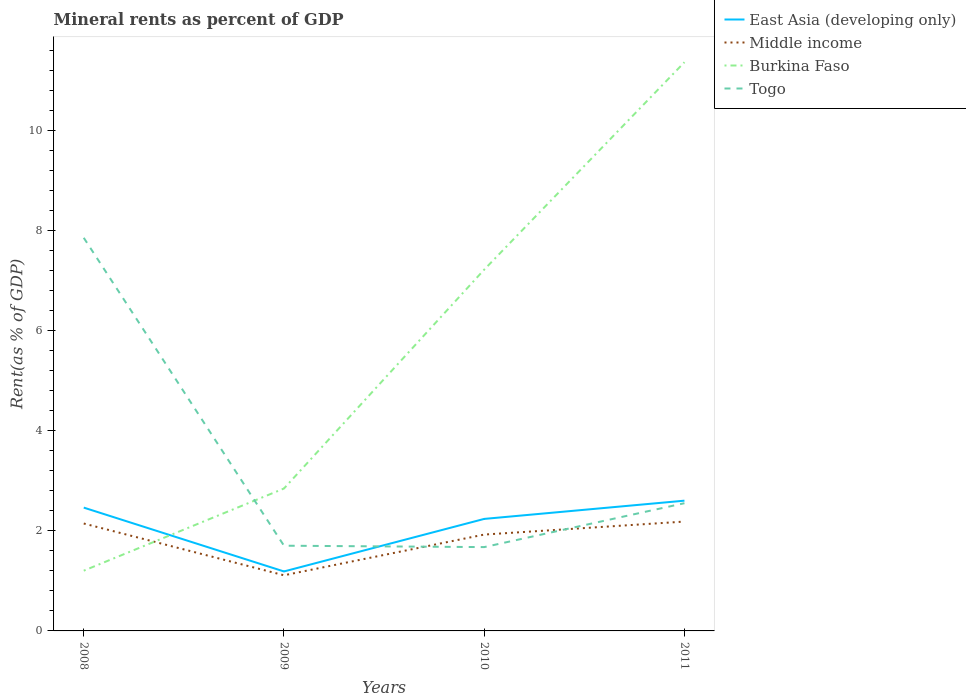How many different coloured lines are there?
Offer a terse response. 4. Does the line corresponding to Togo intersect with the line corresponding to Burkina Faso?
Your answer should be compact. Yes. Is the number of lines equal to the number of legend labels?
Your answer should be very brief. Yes. Across all years, what is the maximum mineral rent in Burkina Faso?
Keep it short and to the point. 1.2. What is the total mineral rent in Togo in the graph?
Give a very brief answer. 0.03. What is the difference between the highest and the second highest mineral rent in Burkina Faso?
Your answer should be very brief. 10.15. What is the difference between the highest and the lowest mineral rent in Middle income?
Offer a terse response. 3. Is the mineral rent in Togo strictly greater than the mineral rent in Burkina Faso over the years?
Offer a very short reply. No. What is the difference between two consecutive major ticks on the Y-axis?
Give a very brief answer. 2. Does the graph contain any zero values?
Your answer should be compact. No. How many legend labels are there?
Offer a very short reply. 4. How are the legend labels stacked?
Offer a very short reply. Vertical. What is the title of the graph?
Ensure brevity in your answer.  Mineral rents as percent of GDP. Does "Vietnam" appear as one of the legend labels in the graph?
Offer a very short reply. No. What is the label or title of the X-axis?
Make the answer very short. Years. What is the label or title of the Y-axis?
Give a very brief answer. Rent(as % of GDP). What is the Rent(as % of GDP) in East Asia (developing only) in 2008?
Make the answer very short. 2.46. What is the Rent(as % of GDP) in Middle income in 2008?
Your response must be concise. 2.14. What is the Rent(as % of GDP) in Burkina Faso in 2008?
Your answer should be compact. 1.2. What is the Rent(as % of GDP) in Togo in 2008?
Provide a short and direct response. 7.85. What is the Rent(as % of GDP) of East Asia (developing only) in 2009?
Provide a short and direct response. 1.19. What is the Rent(as % of GDP) in Middle income in 2009?
Your answer should be very brief. 1.11. What is the Rent(as % of GDP) in Burkina Faso in 2009?
Provide a short and direct response. 2.84. What is the Rent(as % of GDP) of Togo in 2009?
Give a very brief answer. 1.7. What is the Rent(as % of GDP) of East Asia (developing only) in 2010?
Keep it short and to the point. 2.24. What is the Rent(as % of GDP) in Middle income in 2010?
Make the answer very short. 1.92. What is the Rent(as % of GDP) of Burkina Faso in 2010?
Make the answer very short. 7.22. What is the Rent(as % of GDP) in Togo in 2010?
Make the answer very short. 1.67. What is the Rent(as % of GDP) of East Asia (developing only) in 2011?
Offer a very short reply. 2.6. What is the Rent(as % of GDP) in Middle income in 2011?
Ensure brevity in your answer.  2.18. What is the Rent(as % of GDP) in Burkina Faso in 2011?
Keep it short and to the point. 11.36. What is the Rent(as % of GDP) in Togo in 2011?
Give a very brief answer. 2.55. Across all years, what is the maximum Rent(as % of GDP) in East Asia (developing only)?
Make the answer very short. 2.6. Across all years, what is the maximum Rent(as % of GDP) of Middle income?
Your answer should be compact. 2.18. Across all years, what is the maximum Rent(as % of GDP) of Burkina Faso?
Ensure brevity in your answer.  11.36. Across all years, what is the maximum Rent(as % of GDP) in Togo?
Your answer should be very brief. 7.85. Across all years, what is the minimum Rent(as % of GDP) in East Asia (developing only)?
Give a very brief answer. 1.19. Across all years, what is the minimum Rent(as % of GDP) in Middle income?
Your answer should be very brief. 1.11. Across all years, what is the minimum Rent(as % of GDP) in Burkina Faso?
Provide a short and direct response. 1.2. Across all years, what is the minimum Rent(as % of GDP) of Togo?
Offer a very short reply. 1.67. What is the total Rent(as % of GDP) in East Asia (developing only) in the graph?
Offer a terse response. 8.49. What is the total Rent(as % of GDP) of Middle income in the graph?
Your answer should be very brief. 7.36. What is the total Rent(as % of GDP) in Burkina Faso in the graph?
Offer a very short reply. 22.62. What is the total Rent(as % of GDP) of Togo in the graph?
Offer a very short reply. 13.78. What is the difference between the Rent(as % of GDP) of East Asia (developing only) in 2008 and that in 2009?
Your answer should be very brief. 1.28. What is the difference between the Rent(as % of GDP) in Middle income in 2008 and that in 2009?
Offer a very short reply. 1.03. What is the difference between the Rent(as % of GDP) in Burkina Faso in 2008 and that in 2009?
Your response must be concise. -1.64. What is the difference between the Rent(as % of GDP) in Togo in 2008 and that in 2009?
Offer a very short reply. 6.15. What is the difference between the Rent(as % of GDP) in East Asia (developing only) in 2008 and that in 2010?
Provide a succinct answer. 0.23. What is the difference between the Rent(as % of GDP) in Middle income in 2008 and that in 2010?
Provide a succinct answer. 0.22. What is the difference between the Rent(as % of GDP) in Burkina Faso in 2008 and that in 2010?
Keep it short and to the point. -6.01. What is the difference between the Rent(as % of GDP) in Togo in 2008 and that in 2010?
Your answer should be compact. 6.18. What is the difference between the Rent(as % of GDP) of East Asia (developing only) in 2008 and that in 2011?
Your answer should be very brief. -0.14. What is the difference between the Rent(as % of GDP) in Middle income in 2008 and that in 2011?
Your response must be concise. -0.04. What is the difference between the Rent(as % of GDP) of Burkina Faso in 2008 and that in 2011?
Keep it short and to the point. -10.15. What is the difference between the Rent(as % of GDP) of Togo in 2008 and that in 2011?
Provide a succinct answer. 5.3. What is the difference between the Rent(as % of GDP) in East Asia (developing only) in 2009 and that in 2010?
Give a very brief answer. -1.05. What is the difference between the Rent(as % of GDP) in Middle income in 2009 and that in 2010?
Ensure brevity in your answer.  -0.81. What is the difference between the Rent(as % of GDP) of Burkina Faso in 2009 and that in 2010?
Ensure brevity in your answer.  -4.37. What is the difference between the Rent(as % of GDP) in Togo in 2009 and that in 2010?
Your answer should be compact. 0.03. What is the difference between the Rent(as % of GDP) in East Asia (developing only) in 2009 and that in 2011?
Your answer should be very brief. -1.41. What is the difference between the Rent(as % of GDP) in Middle income in 2009 and that in 2011?
Offer a very short reply. -1.07. What is the difference between the Rent(as % of GDP) in Burkina Faso in 2009 and that in 2011?
Provide a succinct answer. -8.51. What is the difference between the Rent(as % of GDP) of Togo in 2009 and that in 2011?
Ensure brevity in your answer.  -0.85. What is the difference between the Rent(as % of GDP) of East Asia (developing only) in 2010 and that in 2011?
Your answer should be very brief. -0.36. What is the difference between the Rent(as % of GDP) in Middle income in 2010 and that in 2011?
Your response must be concise. -0.26. What is the difference between the Rent(as % of GDP) of Burkina Faso in 2010 and that in 2011?
Give a very brief answer. -4.14. What is the difference between the Rent(as % of GDP) of Togo in 2010 and that in 2011?
Provide a short and direct response. -0.88. What is the difference between the Rent(as % of GDP) of East Asia (developing only) in 2008 and the Rent(as % of GDP) of Middle income in 2009?
Keep it short and to the point. 1.35. What is the difference between the Rent(as % of GDP) of East Asia (developing only) in 2008 and the Rent(as % of GDP) of Burkina Faso in 2009?
Your response must be concise. -0.38. What is the difference between the Rent(as % of GDP) of East Asia (developing only) in 2008 and the Rent(as % of GDP) of Togo in 2009?
Offer a very short reply. 0.76. What is the difference between the Rent(as % of GDP) of Middle income in 2008 and the Rent(as % of GDP) of Burkina Faso in 2009?
Ensure brevity in your answer.  -0.7. What is the difference between the Rent(as % of GDP) in Middle income in 2008 and the Rent(as % of GDP) in Togo in 2009?
Offer a very short reply. 0.44. What is the difference between the Rent(as % of GDP) of Burkina Faso in 2008 and the Rent(as % of GDP) of Togo in 2009?
Make the answer very short. -0.5. What is the difference between the Rent(as % of GDP) of East Asia (developing only) in 2008 and the Rent(as % of GDP) of Middle income in 2010?
Your answer should be compact. 0.54. What is the difference between the Rent(as % of GDP) of East Asia (developing only) in 2008 and the Rent(as % of GDP) of Burkina Faso in 2010?
Ensure brevity in your answer.  -4.75. What is the difference between the Rent(as % of GDP) in East Asia (developing only) in 2008 and the Rent(as % of GDP) in Togo in 2010?
Your response must be concise. 0.79. What is the difference between the Rent(as % of GDP) of Middle income in 2008 and the Rent(as % of GDP) of Burkina Faso in 2010?
Offer a very short reply. -5.07. What is the difference between the Rent(as % of GDP) of Middle income in 2008 and the Rent(as % of GDP) of Togo in 2010?
Provide a short and direct response. 0.47. What is the difference between the Rent(as % of GDP) in Burkina Faso in 2008 and the Rent(as % of GDP) in Togo in 2010?
Provide a short and direct response. -0.47. What is the difference between the Rent(as % of GDP) of East Asia (developing only) in 2008 and the Rent(as % of GDP) of Middle income in 2011?
Make the answer very short. 0.28. What is the difference between the Rent(as % of GDP) of East Asia (developing only) in 2008 and the Rent(as % of GDP) of Burkina Faso in 2011?
Offer a very short reply. -8.89. What is the difference between the Rent(as % of GDP) in East Asia (developing only) in 2008 and the Rent(as % of GDP) in Togo in 2011?
Keep it short and to the point. -0.09. What is the difference between the Rent(as % of GDP) in Middle income in 2008 and the Rent(as % of GDP) in Burkina Faso in 2011?
Your response must be concise. -9.21. What is the difference between the Rent(as % of GDP) in Middle income in 2008 and the Rent(as % of GDP) in Togo in 2011?
Your response must be concise. -0.41. What is the difference between the Rent(as % of GDP) in Burkina Faso in 2008 and the Rent(as % of GDP) in Togo in 2011?
Provide a short and direct response. -1.35. What is the difference between the Rent(as % of GDP) of East Asia (developing only) in 2009 and the Rent(as % of GDP) of Middle income in 2010?
Your response must be concise. -0.74. What is the difference between the Rent(as % of GDP) in East Asia (developing only) in 2009 and the Rent(as % of GDP) in Burkina Faso in 2010?
Keep it short and to the point. -6.03. What is the difference between the Rent(as % of GDP) in East Asia (developing only) in 2009 and the Rent(as % of GDP) in Togo in 2010?
Offer a very short reply. -0.49. What is the difference between the Rent(as % of GDP) of Middle income in 2009 and the Rent(as % of GDP) of Burkina Faso in 2010?
Keep it short and to the point. -6.1. What is the difference between the Rent(as % of GDP) of Middle income in 2009 and the Rent(as % of GDP) of Togo in 2010?
Your response must be concise. -0.56. What is the difference between the Rent(as % of GDP) of Burkina Faso in 2009 and the Rent(as % of GDP) of Togo in 2010?
Offer a terse response. 1.17. What is the difference between the Rent(as % of GDP) in East Asia (developing only) in 2009 and the Rent(as % of GDP) in Middle income in 2011?
Provide a succinct answer. -1. What is the difference between the Rent(as % of GDP) in East Asia (developing only) in 2009 and the Rent(as % of GDP) in Burkina Faso in 2011?
Your answer should be compact. -10.17. What is the difference between the Rent(as % of GDP) in East Asia (developing only) in 2009 and the Rent(as % of GDP) in Togo in 2011?
Offer a very short reply. -1.36. What is the difference between the Rent(as % of GDP) of Middle income in 2009 and the Rent(as % of GDP) of Burkina Faso in 2011?
Provide a succinct answer. -10.25. What is the difference between the Rent(as % of GDP) of Middle income in 2009 and the Rent(as % of GDP) of Togo in 2011?
Make the answer very short. -1.44. What is the difference between the Rent(as % of GDP) in Burkina Faso in 2009 and the Rent(as % of GDP) in Togo in 2011?
Your response must be concise. 0.29. What is the difference between the Rent(as % of GDP) in East Asia (developing only) in 2010 and the Rent(as % of GDP) in Middle income in 2011?
Keep it short and to the point. 0.05. What is the difference between the Rent(as % of GDP) of East Asia (developing only) in 2010 and the Rent(as % of GDP) of Burkina Faso in 2011?
Keep it short and to the point. -9.12. What is the difference between the Rent(as % of GDP) of East Asia (developing only) in 2010 and the Rent(as % of GDP) of Togo in 2011?
Offer a terse response. -0.31. What is the difference between the Rent(as % of GDP) of Middle income in 2010 and the Rent(as % of GDP) of Burkina Faso in 2011?
Provide a short and direct response. -9.43. What is the difference between the Rent(as % of GDP) of Middle income in 2010 and the Rent(as % of GDP) of Togo in 2011?
Give a very brief answer. -0.63. What is the difference between the Rent(as % of GDP) in Burkina Faso in 2010 and the Rent(as % of GDP) in Togo in 2011?
Give a very brief answer. 4.66. What is the average Rent(as % of GDP) of East Asia (developing only) per year?
Provide a short and direct response. 2.12. What is the average Rent(as % of GDP) of Middle income per year?
Make the answer very short. 1.84. What is the average Rent(as % of GDP) in Burkina Faso per year?
Keep it short and to the point. 5.65. What is the average Rent(as % of GDP) of Togo per year?
Provide a succinct answer. 3.44. In the year 2008, what is the difference between the Rent(as % of GDP) in East Asia (developing only) and Rent(as % of GDP) in Middle income?
Ensure brevity in your answer.  0.32. In the year 2008, what is the difference between the Rent(as % of GDP) in East Asia (developing only) and Rent(as % of GDP) in Burkina Faso?
Give a very brief answer. 1.26. In the year 2008, what is the difference between the Rent(as % of GDP) in East Asia (developing only) and Rent(as % of GDP) in Togo?
Give a very brief answer. -5.39. In the year 2008, what is the difference between the Rent(as % of GDP) of Middle income and Rent(as % of GDP) of Burkina Faso?
Keep it short and to the point. 0.94. In the year 2008, what is the difference between the Rent(as % of GDP) of Middle income and Rent(as % of GDP) of Togo?
Offer a terse response. -5.71. In the year 2008, what is the difference between the Rent(as % of GDP) in Burkina Faso and Rent(as % of GDP) in Togo?
Offer a very short reply. -6.65. In the year 2009, what is the difference between the Rent(as % of GDP) of East Asia (developing only) and Rent(as % of GDP) of Middle income?
Your response must be concise. 0.08. In the year 2009, what is the difference between the Rent(as % of GDP) in East Asia (developing only) and Rent(as % of GDP) in Burkina Faso?
Make the answer very short. -1.66. In the year 2009, what is the difference between the Rent(as % of GDP) in East Asia (developing only) and Rent(as % of GDP) in Togo?
Offer a terse response. -0.51. In the year 2009, what is the difference between the Rent(as % of GDP) in Middle income and Rent(as % of GDP) in Burkina Faso?
Give a very brief answer. -1.73. In the year 2009, what is the difference between the Rent(as % of GDP) of Middle income and Rent(as % of GDP) of Togo?
Keep it short and to the point. -0.59. In the year 2009, what is the difference between the Rent(as % of GDP) of Burkina Faso and Rent(as % of GDP) of Togo?
Make the answer very short. 1.14. In the year 2010, what is the difference between the Rent(as % of GDP) in East Asia (developing only) and Rent(as % of GDP) in Middle income?
Offer a very short reply. 0.31. In the year 2010, what is the difference between the Rent(as % of GDP) of East Asia (developing only) and Rent(as % of GDP) of Burkina Faso?
Provide a short and direct response. -4.98. In the year 2010, what is the difference between the Rent(as % of GDP) of East Asia (developing only) and Rent(as % of GDP) of Togo?
Give a very brief answer. 0.56. In the year 2010, what is the difference between the Rent(as % of GDP) of Middle income and Rent(as % of GDP) of Burkina Faso?
Offer a terse response. -5.29. In the year 2010, what is the difference between the Rent(as % of GDP) of Middle income and Rent(as % of GDP) of Togo?
Your answer should be very brief. 0.25. In the year 2010, what is the difference between the Rent(as % of GDP) of Burkina Faso and Rent(as % of GDP) of Togo?
Your answer should be very brief. 5.54. In the year 2011, what is the difference between the Rent(as % of GDP) of East Asia (developing only) and Rent(as % of GDP) of Middle income?
Your answer should be very brief. 0.42. In the year 2011, what is the difference between the Rent(as % of GDP) of East Asia (developing only) and Rent(as % of GDP) of Burkina Faso?
Make the answer very short. -8.76. In the year 2011, what is the difference between the Rent(as % of GDP) of East Asia (developing only) and Rent(as % of GDP) of Togo?
Make the answer very short. 0.05. In the year 2011, what is the difference between the Rent(as % of GDP) in Middle income and Rent(as % of GDP) in Burkina Faso?
Offer a terse response. -9.17. In the year 2011, what is the difference between the Rent(as % of GDP) of Middle income and Rent(as % of GDP) of Togo?
Ensure brevity in your answer.  -0.37. In the year 2011, what is the difference between the Rent(as % of GDP) of Burkina Faso and Rent(as % of GDP) of Togo?
Provide a succinct answer. 8.81. What is the ratio of the Rent(as % of GDP) of East Asia (developing only) in 2008 to that in 2009?
Give a very brief answer. 2.07. What is the ratio of the Rent(as % of GDP) in Middle income in 2008 to that in 2009?
Your answer should be compact. 1.93. What is the ratio of the Rent(as % of GDP) in Burkina Faso in 2008 to that in 2009?
Make the answer very short. 0.42. What is the ratio of the Rent(as % of GDP) of Togo in 2008 to that in 2009?
Offer a very short reply. 4.61. What is the ratio of the Rent(as % of GDP) of East Asia (developing only) in 2008 to that in 2010?
Ensure brevity in your answer.  1.1. What is the ratio of the Rent(as % of GDP) of Middle income in 2008 to that in 2010?
Your response must be concise. 1.11. What is the ratio of the Rent(as % of GDP) of Burkina Faso in 2008 to that in 2010?
Make the answer very short. 0.17. What is the ratio of the Rent(as % of GDP) in Togo in 2008 to that in 2010?
Your answer should be very brief. 4.69. What is the ratio of the Rent(as % of GDP) in East Asia (developing only) in 2008 to that in 2011?
Make the answer very short. 0.95. What is the ratio of the Rent(as % of GDP) in Middle income in 2008 to that in 2011?
Your answer should be compact. 0.98. What is the ratio of the Rent(as % of GDP) in Burkina Faso in 2008 to that in 2011?
Make the answer very short. 0.11. What is the ratio of the Rent(as % of GDP) in Togo in 2008 to that in 2011?
Ensure brevity in your answer.  3.08. What is the ratio of the Rent(as % of GDP) in East Asia (developing only) in 2009 to that in 2010?
Provide a short and direct response. 0.53. What is the ratio of the Rent(as % of GDP) of Middle income in 2009 to that in 2010?
Offer a very short reply. 0.58. What is the ratio of the Rent(as % of GDP) in Burkina Faso in 2009 to that in 2010?
Offer a very short reply. 0.39. What is the ratio of the Rent(as % of GDP) in Togo in 2009 to that in 2010?
Your answer should be very brief. 1.02. What is the ratio of the Rent(as % of GDP) in East Asia (developing only) in 2009 to that in 2011?
Offer a very short reply. 0.46. What is the ratio of the Rent(as % of GDP) of Middle income in 2009 to that in 2011?
Give a very brief answer. 0.51. What is the ratio of the Rent(as % of GDP) in Burkina Faso in 2009 to that in 2011?
Provide a succinct answer. 0.25. What is the ratio of the Rent(as % of GDP) of Togo in 2009 to that in 2011?
Keep it short and to the point. 0.67. What is the ratio of the Rent(as % of GDP) of East Asia (developing only) in 2010 to that in 2011?
Ensure brevity in your answer.  0.86. What is the ratio of the Rent(as % of GDP) in Middle income in 2010 to that in 2011?
Your answer should be compact. 0.88. What is the ratio of the Rent(as % of GDP) in Burkina Faso in 2010 to that in 2011?
Offer a terse response. 0.64. What is the ratio of the Rent(as % of GDP) of Togo in 2010 to that in 2011?
Ensure brevity in your answer.  0.66. What is the difference between the highest and the second highest Rent(as % of GDP) of East Asia (developing only)?
Provide a succinct answer. 0.14. What is the difference between the highest and the second highest Rent(as % of GDP) in Middle income?
Offer a very short reply. 0.04. What is the difference between the highest and the second highest Rent(as % of GDP) in Burkina Faso?
Give a very brief answer. 4.14. What is the difference between the highest and the second highest Rent(as % of GDP) of Togo?
Ensure brevity in your answer.  5.3. What is the difference between the highest and the lowest Rent(as % of GDP) in East Asia (developing only)?
Give a very brief answer. 1.41. What is the difference between the highest and the lowest Rent(as % of GDP) in Middle income?
Provide a succinct answer. 1.07. What is the difference between the highest and the lowest Rent(as % of GDP) in Burkina Faso?
Ensure brevity in your answer.  10.15. What is the difference between the highest and the lowest Rent(as % of GDP) in Togo?
Keep it short and to the point. 6.18. 